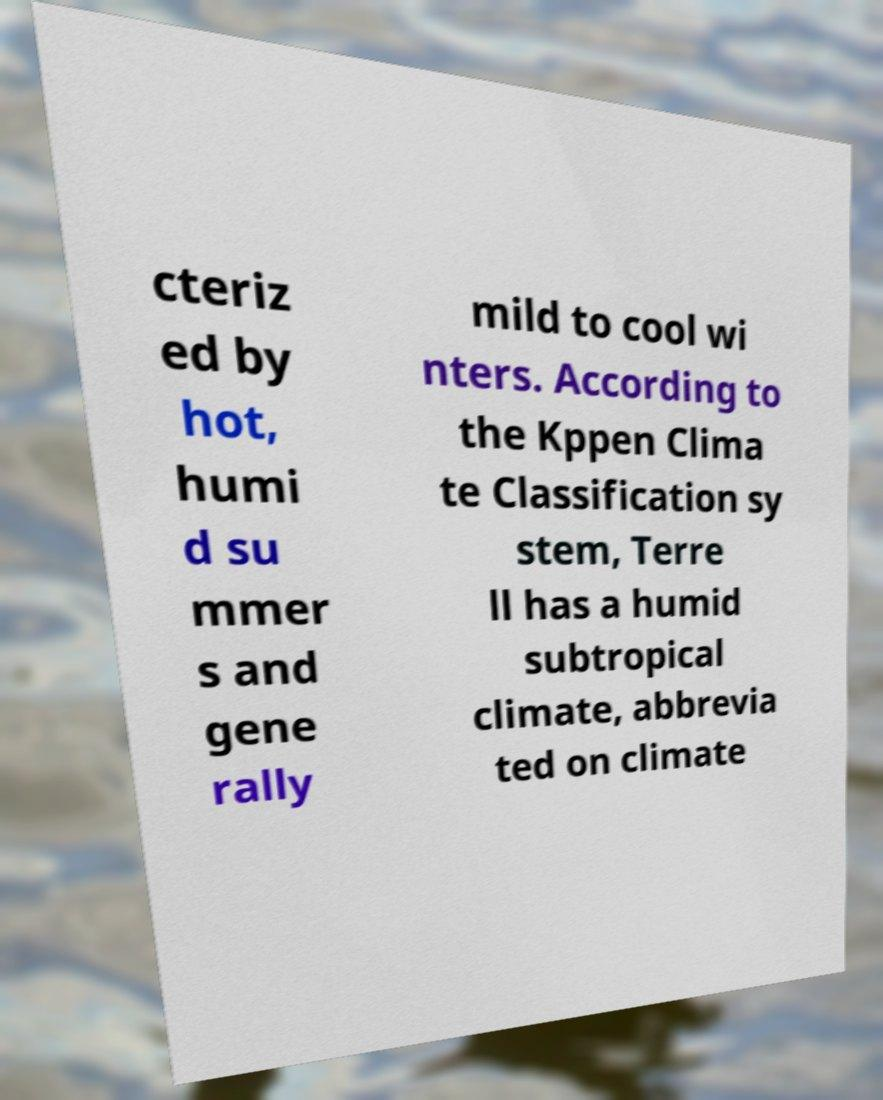Please read and relay the text visible in this image. What does it say? cteriz ed by hot, humi d su mmer s and gene rally mild to cool wi nters. According to the Kppen Clima te Classification sy stem, Terre ll has a humid subtropical climate, abbrevia ted on climate 